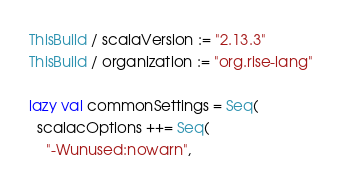Convert code to text. <code><loc_0><loc_0><loc_500><loc_500><_Scala_>ThisBuild / scalaVersion := "2.13.3"
ThisBuild / organization := "org.rise-lang"

lazy val commonSettings = Seq(
  scalacOptions ++= Seq(
    "-Wunused:nowarn",</code> 